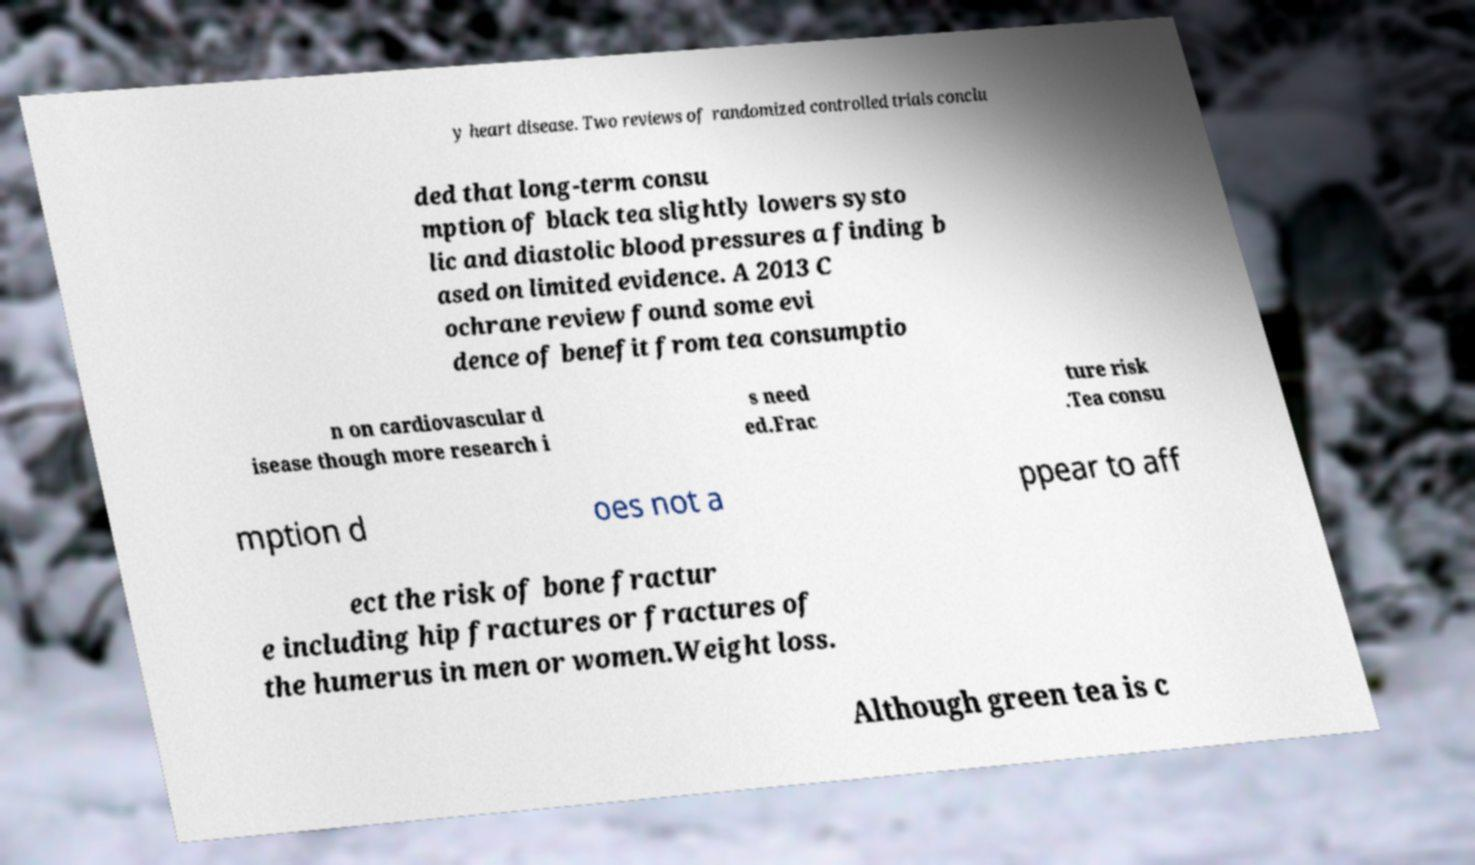I need the written content from this picture converted into text. Can you do that? y heart disease. Two reviews of randomized controlled trials conclu ded that long-term consu mption of black tea slightly lowers systo lic and diastolic blood pressures a finding b ased on limited evidence. A 2013 C ochrane review found some evi dence of benefit from tea consumptio n on cardiovascular d isease though more research i s need ed.Frac ture risk .Tea consu mption d oes not a ppear to aff ect the risk of bone fractur e including hip fractures or fractures of the humerus in men or women.Weight loss. Although green tea is c 